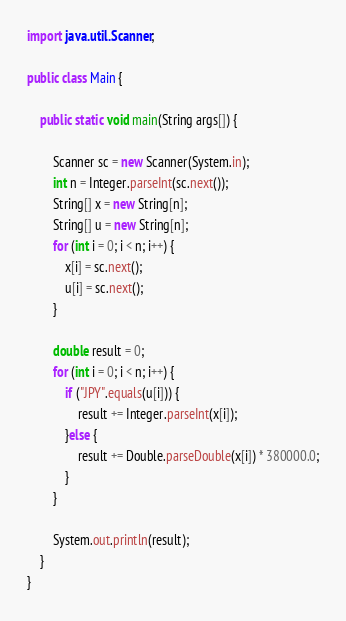<code> <loc_0><loc_0><loc_500><loc_500><_Java_>import java.util.Scanner;

public class Main {

    public static void main(String args[]) {

        Scanner sc = new Scanner(System.in);
        int n = Integer.parseInt(sc.next());
        String[] x = new String[n];
        String[] u = new String[n];
        for (int i = 0; i < n; i++) {
            x[i] = sc.next();
            u[i] = sc.next();
        }

        double result = 0;
        for (int i = 0; i < n; i++) {
            if ("JPY".equals(u[i])) {
                result += Integer.parseInt(x[i]);
            }else {
                result += Double.parseDouble(x[i]) * 380000.0;
            }
        }

        System.out.println(result);
    }
}</code> 